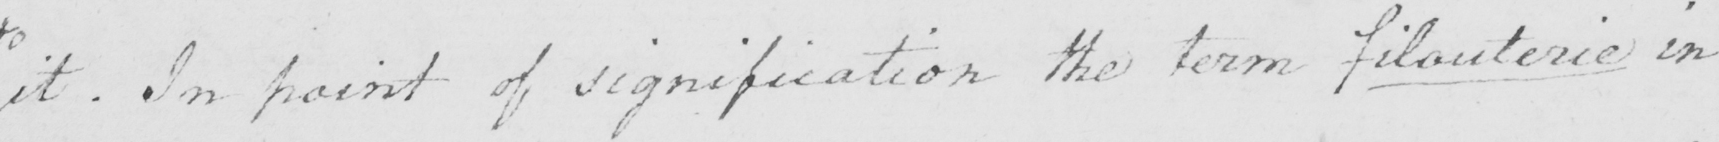Please transcribe the handwritten text in this image. it . In point of signification the term filouterie in 